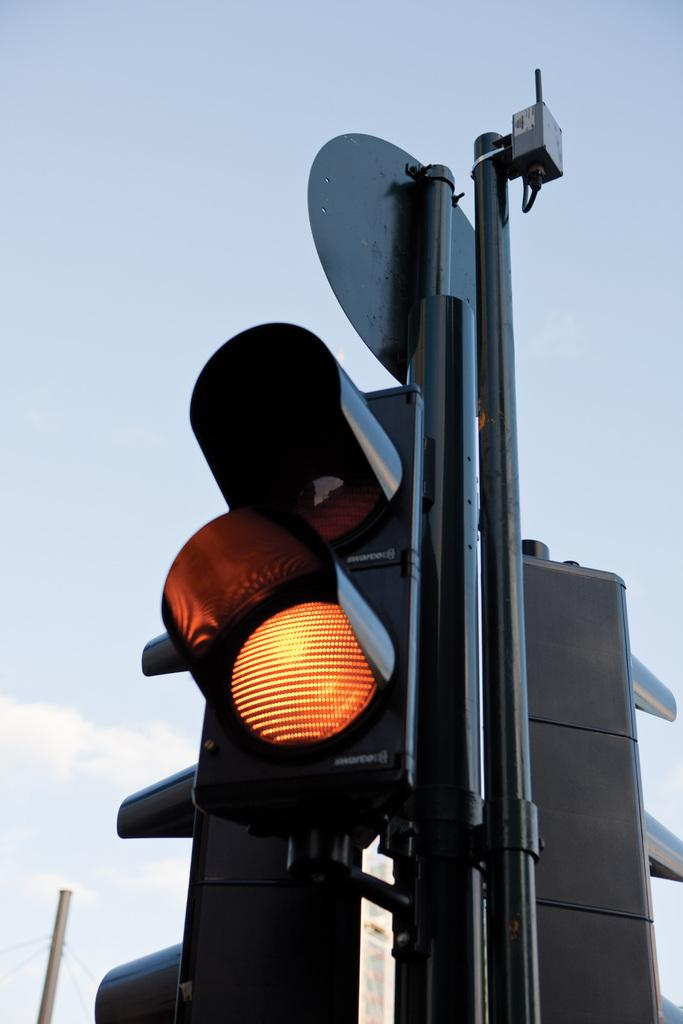What can be seen on the poles in the image? There are poles with traffic signals in the image. What is visible in the background of the image? There is sky visible in the background of the image. Can you describe any other poles in the image? Yes, there is a pole in the background of the image. What time of day is it in the image, given the presence of a pear? There is no pear present in the image, so it cannot be used to determine the time of day. 